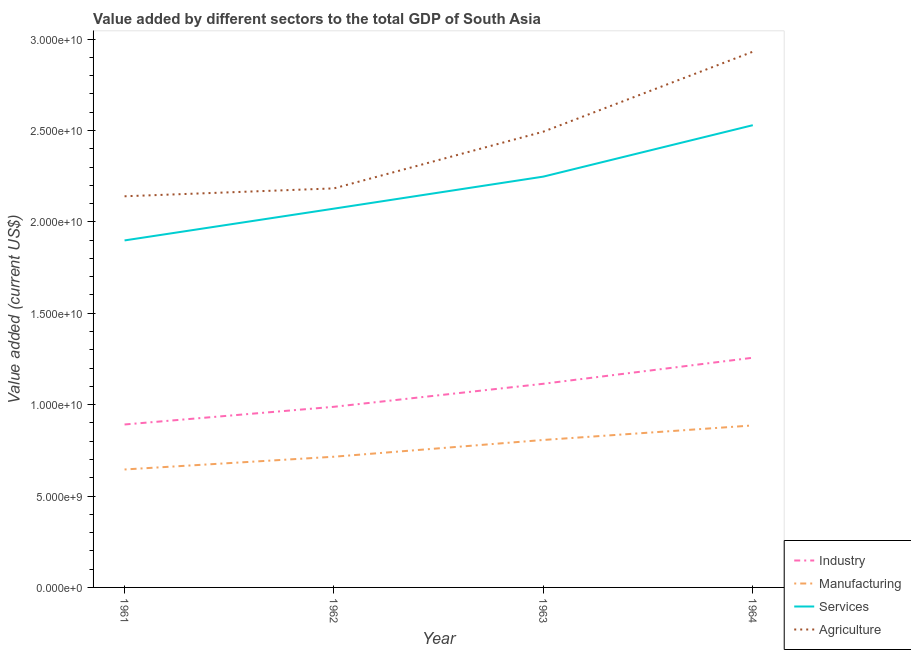Does the line corresponding to value added by industrial sector intersect with the line corresponding to value added by services sector?
Provide a short and direct response. No. What is the value added by manufacturing sector in 1962?
Make the answer very short. 7.15e+09. Across all years, what is the maximum value added by agricultural sector?
Your answer should be compact. 2.93e+1. Across all years, what is the minimum value added by services sector?
Ensure brevity in your answer.  1.90e+1. In which year was the value added by agricultural sector maximum?
Your answer should be compact. 1964. What is the total value added by industrial sector in the graph?
Offer a very short reply. 4.25e+1. What is the difference between the value added by industrial sector in 1961 and that in 1963?
Your answer should be compact. -2.23e+09. What is the difference between the value added by industrial sector in 1962 and the value added by services sector in 1964?
Your answer should be compact. -1.54e+1. What is the average value added by manufacturing sector per year?
Your answer should be very brief. 7.63e+09. In the year 1961, what is the difference between the value added by agricultural sector and value added by industrial sector?
Offer a very short reply. 1.25e+1. What is the ratio of the value added by manufacturing sector in 1961 to that in 1962?
Your answer should be very brief. 0.9. Is the value added by industrial sector in 1961 less than that in 1964?
Offer a terse response. Yes. What is the difference between the highest and the second highest value added by manufacturing sector?
Your answer should be compact. 7.95e+08. What is the difference between the highest and the lowest value added by services sector?
Offer a very short reply. 6.30e+09. Is the sum of the value added by agricultural sector in 1961 and 1963 greater than the maximum value added by industrial sector across all years?
Give a very brief answer. Yes. Is the value added by agricultural sector strictly greater than the value added by services sector over the years?
Offer a terse response. Yes. Is the value added by industrial sector strictly less than the value added by agricultural sector over the years?
Your response must be concise. Yes. How many years are there in the graph?
Provide a succinct answer. 4. What is the difference between two consecutive major ticks on the Y-axis?
Give a very brief answer. 5.00e+09. Does the graph contain grids?
Offer a terse response. No. Where does the legend appear in the graph?
Your answer should be very brief. Bottom right. How many legend labels are there?
Ensure brevity in your answer.  4. What is the title of the graph?
Offer a very short reply. Value added by different sectors to the total GDP of South Asia. What is the label or title of the X-axis?
Your response must be concise. Year. What is the label or title of the Y-axis?
Provide a succinct answer. Value added (current US$). What is the Value added (current US$) in Industry in 1961?
Ensure brevity in your answer.  8.91e+09. What is the Value added (current US$) in Manufacturing in 1961?
Provide a succinct answer. 6.45e+09. What is the Value added (current US$) in Services in 1961?
Keep it short and to the point. 1.90e+1. What is the Value added (current US$) in Agriculture in 1961?
Offer a very short reply. 2.14e+1. What is the Value added (current US$) of Industry in 1962?
Your answer should be very brief. 9.88e+09. What is the Value added (current US$) of Manufacturing in 1962?
Your answer should be compact. 7.15e+09. What is the Value added (current US$) in Services in 1962?
Make the answer very short. 2.07e+1. What is the Value added (current US$) of Agriculture in 1962?
Your answer should be compact. 2.18e+1. What is the Value added (current US$) in Industry in 1963?
Offer a very short reply. 1.11e+1. What is the Value added (current US$) of Manufacturing in 1963?
Offer a very short reply. 8.07e+09. What is the Value added (current US$) in Services in 1963?
Offer a very short reply. 2.25e+1. What is the Value added (current US$) of Agriculture in 1963?
Your response must be concise. 2.49e+1. What is the Value added (current US$) in Industry in 1964?
Provide a short and direct response. 1.26e+1. What is the Value added (current US$) of Manufacturing in 1964?
Give a very brief answer. 8.86e+09. What is the Value added (current US$) in Services in 1964?
Your response must be concise. 2.53e+1. What is the Value added (current US$) of Agriculture in 1964?
Your answer should be compact. 2.93e+1. Across all years, what is the maximum Value added (current US$) in Industry?
Your answer should be very brief. 1.26e+1. Across all years, what is the maximum Value added (current US$) of Manufacturing?
Offer a very short reply. 8.86e+09. Across all years, what is the maximum Value added (current US$) of Services?
Make the answer very short. 2.53e+1. Across all years, what is the maximum Value added (current US$) in Agriculture?
Provide a succinct answer. 2.93e+1. Across all years, what is the minimum Value added (current US$) of Industry?
Give a very brief answer. 8.91e+09. Across all years, what is the minimum Value added (current US$) in Manufacturing?
Provide a short and direct response. 6.45e+09. Across all years, what is the minimum Value added (current US$) in Services?
Give a very brief answer. 1.90e+1. Across all years, what is the minimum Value added (current US$) in Agriculture?
Keep it short and to the point. 2.14e+1. What is the total Value added (current US$) of Industry in the graph?
Ensure brevity in your answer.  4.25e+1. What is the total Value added (current US$) in Manufacturing in the graph?
Ensure brevity in your answer.  3.05e+1. What is the total Value added (current US$) of Services in the graph?
Provide a succinct answer. 8.75e+1. What is the total Value added (current US$) of Agriculture in the graph?
Give a very brief answer. 9.75e+1. What is the difference between the Value added (current US$) of Industry in 1961 and that in 1962?
Provide a succinct answer. -9.68e+08. What is the difference between the Value added (current US$) in Manufacturing in 1961 and that in 1962?
Your response must be concise. -6.98e+08. What is the difference between the Value added (current US$) of Services in 1961 and that in 1962?
Keep it short and to the point. -1.74e+09. What is the difference between the Value added (current US$) in Agriculture in 1961 and that in 1962?
Your answer should be compact. -4.32e+08. What is the difference between the Value added (current US$) of Industry in 1961 and that in 1963?
Offer a terse response. -2.23e+09. What is the difference between the Value added (current US$) of Manufacturing in 1961 and that in 1963?
Give a very brief answer. -1.61e+09. What is the difference between the Value added (current US$) in Services in 1961 and that in 1963?
Provide a short and direct response. -3.49e+09. What is the difference between the Value added (current US$) in Agriculture in 1961 and that in 1963?
Give a very brief answer. -3.54e+09. What is the difference between the Value added (current US$) in Industry in 1961 and that in 1964?
Offer a very short reply. -3.65e+09. What is the difference between the Value added (current US$) in Manufacturing in 1961 and that in 1964?
Provide a succinct answer. -2.41e+09. What is the difference between the Value added (current US$) in Services in 1961 and that in 1964?
Ensure brevity in your answer.  -6.30e+09. What is the difference between the Value added (current US$) of Agriculture in 1961 and that in 1964?
Your answer should be very brief. -7.91e+09. What is the difference between the Value added (current US$) of Industry in 1962 and that in 1963?
Ensure brevity in your answer.  -1.26e+09. What is the difference between the Value added (current US$) in Manufacturing in 1962 and that in 1963?
Give a very brief answer. -9.17e+08. What is the difference between the Value added (current US$) in Services in 1962 and that in 1963?
Give a very brief answer. -1.75e+09. What is the difference between the Value added (current US$) in Agriculture in 1962 and that in 1963?
Your answer should be compact. -3.10e+09. What is the difference between the Value added (current US$) of Industry in 1962 and that in 1964?
Make the answer very short. -2.68e+09. What is the difference between the Value added (current US$) in Manufacturing in 1962 and that in 1964?
Keep it short and to the point. -1.71e+09. What is the difference between the Value added (current US$) of Services in 1962 and that in 1964?
Provide a succinct answer. -4.57e+09. What is the difference between the Value added (current US$) of Agriculture in 1962 and that in 1964?
Offer a terse response. -7.48e+09. What is the difference between the Value added (current US$) of Industry in 1963 and that in 1964?
Offer a terse response. -1.42e+09. What is the difference between the Value added (current US$) in Manufacturing in 1963 and that in 1964?
Your answer should be compact. -7.95e+08. What is the difference between the Value added (current US$) in Services in 1963 and that in 1964?
Provide a short and direct response. -2.81e+09. What is the difference between the Value added (current US$) in Agriculture in 1963 and that in 1964?
Keep it short and to the point. -4.37e+09. What is the difference between the Value added (current US$) in Industry in 1961 and the Value added (current US$) in Manufacturing in 1962?
Provide a short and direct response. 1.76e+09. What is the difference between the Value added (current US$) in Industry in 1961 and the Value added (current US$) in Services in 1962?
Make the answer very short. -1.18e+1. What is the difference between the Value added (current US$) in Industry in 1961 and the Value added (current US$) in Agriculture in 1962?
Provide a succinct answer. -1.29e+1. What is the difference between the Value added (current US$) of Manufacturing in 1961 and the Value added (current US$) of Services in 1962?
Your answer should be compact. -1.43e+1. What is the difference between the Value added (current US$) of Manufacturing in 1961 and the Value added (current US$) of Agriculture in 1962?
Offer a terse response. -1.54e+1. What is the difference between the Value added (current US$) of Services in 1961 and the Value added (current US$) of Agriculture in 1962?
Give a very brief answer. -2.85e+09. What is the difference between the Value added (current US$) of Industry in 1961 and the Value added (current US$) of Manufacturing in 1963?
Provide a succinct answer. 8.47e+08. What is the difference between the Value added (current US$) in Industry in 1961 and the Value added (current US$) in Services in 1963?
Give a very brief answer. -1.36e+1. What is the difference between the Value added (current US$) in Industry in 1961 and the Value added (current US$) in Agriculture in 1963?
Give a very brief answer. -1.60e+1. What is the difference between the Value added (current US$) in Manufacturing in 1961 and the Value added (current US$) in Services in 1963?
Offer a terse response. -1.60e+1. What is the difference between the Value added (current US$) of Manufacturing in 1961 and the Value added (current US$) of Agriculture in 1963?
Provide a succinct answer. -1.85e+1. What is the difference between the Value added (current US$) of Services in 1961 and the Value added (current US$) of Agriculture in 1963?
Your answer should be very brief. -5.95e+09. What is the difference between the Value added (current US$) in Industry in 1961 and the Value added (current US$) in Manufacturing in 1964?
Your answer should be very brief. 5.20e+07. What is the difference between the Value added (current US$) in Industry in 1961 and the Value added (current US$) in Services in 1964?
Give a very brief answer. -1.64e+1. What is the difference between the Value added (current US$) in Industry in 1961 and the Value added (current US$) in Agriculture in 1964?
Your response must be concise. -2.04e+1. What is the difference between the Value added (current US$) of Manufacturing in 1961 and the Value added (current US$) of Services in 1964?
Provide a succinct answer. -1.88e+1. What is the difference between the Value added (current US$) in Manufacturing in 1961 and the Value added (current US$) in Agriculture in 1964?
Ensure brevity in your answer.  -2.29e+1. What is the difference between the Value added (current US$) of Services in 1961 and the Value added (current US$) of Agriculture in 1964?
Make the answer very short. -1.03e+1. What is the difference between the Value added (current US$) in Industry in 1962 and the Value added (current US$) in Manufacturing in 1963?
Make the answer very short. 1.81e+09. What is the difference between the Value added (current US$) of Industry in 1962 and the Value added (current US$) of Services in 1963?
Give a very brief answer. -1.26e+1. What is the difference between the Value added (current US$) of Industry in 1962 and the Value added (current US$) of Agriculture in 1963?
Offer a very short reply. -1.51e+1. What is the difference between the Value added (current US$) in Manufacturing in 1962 and the Value added (current US$) in Services in 1963?
Provide a succinct answer. -1.53e+1. What is the difference between the Value added (current US$) in Manufacturing in 1962 and the Value added (current US$) in Agriculture in 1963?
Provide a short and direct response. -1.78e+1. What is the difference between the Value added (current US$) of Services in 1962 and the Value added (current US$) of Agriculture in 1963?
Make the answer very short. -4.21e+09. What is the difference between the Value added (current US$) in Industry in 1962 and the Value added (current US$) in Manufacturing in 1964?
Offer a terse response. 1.02e+09. What is the difference between the Value added (current US$) in Industry in 1962 and the Value added (current US$) in Services in 1964?
Your response must be concise. -1.54e+1. What is the difference between the Value added (current US$) of Industry in 1962 and the Value added (current US$) of Agriculture in 1964?
Offer a very short reply. -1.94e+1. What is the difference between the Value added (current US$) in Manufacturing in 1962 and the Value added (current US$) in Services in 1964?
Provide a short and direct response. -1.81e+1. What is the difference between the Value added (current US$) in Manufacturing in 1962 and the Value added (current US$) in Agriculture in 1964?
Offer a very short reply. -2.22e+1. What is the difference between the Value added (current US$) of Services in 1962 and the Value added (current US$) of Agriculture in 1964?
Ensure brevity in your answer.  -8.58e+09. What is the difference between the Value added (current US$) in Industry in 1963 and the Value added (current US$) in Manufacturing in 1964?
Provide a short and direct response. 2.28e+09. What is the difference between the Value added (current US$) in Industry in 1963 and the Value added (current US$) in Services in 1964?
Your answer should be very brief. -1.41e+1. What is the difference between the Value added (current US$) of Industry in 1963 and the Value added (current US$) of Agriculture in 1964?
Offer a terse response. -1.82e+1. What is the difference between the Value added (current US$) in Manufacturing in 1963 and the Value added (current US$) in Services in 1964?
Offer a terse response. -1.72e+1. What is the difference between the Value added (current US$) in Manufacturing in 1963 and the Value added (current US$) in Agriculture in 1964?
Your response must be concise. -2.12e+1. What is the difference between the Value added (current US$) in Services in 1963 and the Value added (current US$) in Agriculture in 1964?
Ensure brevity in your answer.  -6.83e+09. What is the average Value added (current US$) of Industry per year?
Give a very brief answer. 1.06e+1. What is the average Value added (current US$) in Manufacturing per year?
Your response must be concise. 7.63e+09. What is the average Value added (current US$) of Services per year?
Make the answer very short. 2.19e+1. What is the average Value added (current US$) in Agriculture per year?
Offer a very short reply. 2.44e+1. In the year 1961, what is the difference between the Value added (current US$) in Industry and Value added (current US$) in Manufacturing?
Keep it short and to the point. 2.46e+09. In the year 1961, what is the difference between the Value added (current US$) in Industry and Value added (current US$) in Services?
Give a very brief answer. -1.01e+1. In the year 1961, what is the difference between the Value added (current US$) of Industry and Value added (current US$) of Agriculture?
Offer a terse response. -1.25e+1. In the year 1961, what is the difference between the Value added (current US$) of Manufacturing and Value added (current US$) of Services?
Give a very brief answer. -1.25e+1. In the year 1961, what is the difference between the Value added (current US$) in Manufacturing and Value added (current US$) in Agriculture?
Your answer should be compact. -1.49e+1. In the year 1961, what is the difference between the Value added (current US$) of Services and Value added (current US$) of Agriculture?
Your answer should be compact. -2.42e+09. In the year 1962, what is the difference between the Value added (current US$) of Industry and Value added (current US$) of Manufacturing?
Offer a very short reply. 2.73e+09. In the year 1962, what is the difference between the Value added (current US$) of Industry and Value added (current US$) of Services?
Offer a very short reply. -1.08e+1. In the year 1962, what is the difference between the Value added (current US$) of Industry and Value added (current US$) of Agriculture?
Your answer should be very brief. -1.19e+1. In the year 1962, what is the difference between the Value added (current US$) of Manufacturing and Value added (current US$) of Services?
Make the answer very short. -1.36e+1. In the year 1962, what is the difference between the Value added (current US$) of Manufacturing and Value added (current US$) of Agriculture?
Offer a terse response. -1.47e+1. In the year 1962, what is the difference between the Value added (current US$) of Services and Value added (current US$) of Agriculture?
Keep it short and to the point. -1.11e+09. In the year 1963, what is the difference between the Value added (current US$) in Industry and Value added (current US$) in Manufacturing?
Offer a terse response. 3.07e+09. In the year 1963, what is the difference between the Value added (current US$) in Industry and Value added (current US$) in Services?
Ensure brevity in your answer.  -1.13e+1. In the year 1963, what is the difference between the Value added (current US$) in Industry and Value added (current US$) in Agriculture?
Your response must be concise. -1.38e+1. In the year 1963, what is the difference between the Value added (current US$) in Manufacturing and Value added (current US$) in Services?
Your response must be concise. -1.44e+1. In the year 1963, what is the difference between the Value added (current US$) of Manufacturing and Value added (current US$) of Agriculture?
Your answer should be compact. -1.69e+1. In the year 1963, what is the difference between the Value added (current US$) of Services and Value added (current US$) of Agriculture?
Give a very brief answer. -2.46e+09. In the year 1964, what is the difference between the Value added (current US$) in Industry and Value added (current US$) in Manufacturing?
Offer a very short reply. 3.70e+09. In the year 1964, what is the difference between the Value added (current US$) in Industry and Value added (current US$) in Services?
Your response must be concise. -1.27e+1. In the year 1964, what is the difference between the Value added (current US$) of Industry and Value added (current US$) of Agriculture?
Provide a short and direct response. -1.67e+1. In the year 1964, what is the difference between the Value added (current US$) in Manufacturing and Value added (current US$) in Services?
Offer a very short reply. -1.64e+1. In the year 1964, what is the difference between the Value added (current US$) of Manufacturing and Value added (current US$) of Agriculture?
Provide a succinct answer. -2.04e+1. In the year 1964, what is the difference between the Value added (current US$) of Services and Value added (current US$) of Agriculture?
Keep it short and to the point. -4.02e+09. What is the ratio of the Value added (current US$) of Industry in 1961 to that in 1962?
Offer a terse response. 0.9. What is the ratio of the Value added (current US$) of Manufacturing in 1961 to that in 1962?
Give a very brief answer. 0.9. What is the ratio of the Value added (current US$) in Services in 1961 to that in 1962?
Make the answer very short. 0.92. What is the ratio of the Value added (current US$) in Agriculture in 1961 to that in 1962?
Ensure brevity in your answer.  0.98. What is the ratio of the Value added (current US$) in Industry in 1961 to that in 1963?
Your response must be concise. 0.8. What is the ratio of the Value added (current US$) of Manufacturing in 1961 to that in 1963?
Your answer should be compact. 0.8. What is the ratio of the Value added (current US$) of Services in 1961 to that in 1963?
Give a very brief answer. 0.84. What is the ratio of the Value added (current US$) of Agriculture in 1961 to that in 1963?
Your answer should be compact. 0.86. What is the ratio of the Value added (current US$) of Industry in 1961 to that in 1964?
Offer a terse response. 0.71. What is the ratio of the Value added (current US$) in Manufacturing in 1961 to that in 1964?
Your answer should be very brief. 0.73. What is the ratio of the Value added (current US$) of Services in 1961 to that in 1964?
Offer a terse response. 0.75. What is the ratio of the Value added (current US$) of Agriculture in 1961 to that in 1964?
Offer a very short reply. 0.73. What is the ratio of the Value added (current US$) in Industry in 1962 to that in 1963?
Offer a terse response. 0.89. What is the ratio of the Value added (current US$) of Manufacturing in 1962 to that in 1963?
Offer a very short reply. 0.89. What is the ratio of the Value added (current US$) in Services in 1962 to that in 1963?
Your answer should be compact. 0.92. What is the ratio of the Value added (current US$) of Agriculture in 1962 to that in 1963?
Make the answer very short. 0.88. What is the ratio of the Value added (current US$) of Industry in 1962 to that in 1964?
Your answer should be very brief. 0.79. What is the ratio of the Value added (current US$) of Manufacturing in 1962 to that in 1964?
Keep it short and to the point. 0.81. What is the ratio of the Value added (current US$) in Services in 1962 to that in 1964?
Provide a succinct answer. 0.82. What is the ratio of the Value added (current US$) in Agriculture in 1962 to that in 1964?
Your answer should be compact. 0.74. What is the ratio of the Value added (current US$) in Industry in 1963 to that in 1964?
Your answer should be compact. 0.89. What is the ratio of the Value added (current US$) in Manufacturing in 1963 to that in 1964?
Your answer should be very brief. 0.91. What is the ratio of the Value added (current US$) of Services in 1963 to that in 1964?
Your response must be concise. 0.89. What is the ratio of the Value added (current US$) of Agriculture in 1963 to that in 1964?
Ensure brevity in your answer.  0.85. What is the difference between the highest and the second highest Value added (current US$) in Industry?
Your response must be concise. 1.42e+09. What is the difference between the highest and the second highest Value added (current US$) of Manufacturing?
Provide a succinct answer. 7.95e+08. What is the difference between the highest and the second highest Value added (current US$) in Services?
Make the answer very short. 2.81e+09. What is the difference between the highest and the second highest Value added (current US$) in Agriculture?
Provide a short and direct response. 4.37e+09. What is the difference between the highest and the lowest Value added (current US$) of Industry?
Make the answer very short. 3.65e+09. What is the difference between the highest and the lowest Value added (current US$) in Manufacturing?
Provide a short and direct response. 2.41e+09. What is the difference between the highest and the lowest Value added (current US$) of Services?
Your answer should be compact. 6.30e+09. What is the difference between the highest and the lowest Value added (current US$) of Agriculture?
Give a very brief answer. 7.91e+09. 